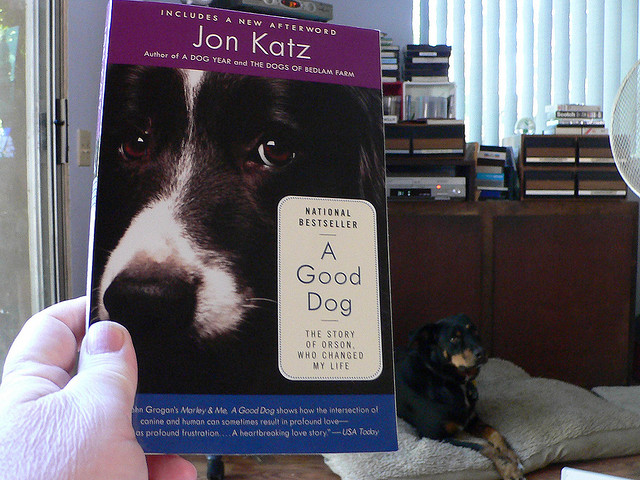What is the subject of the book being held? The book, titled 'A Good Dog,' appears to be about a personal journey with a dog, possibly discussing the impact of the dog on the author's life as suggested by the subtitle. 